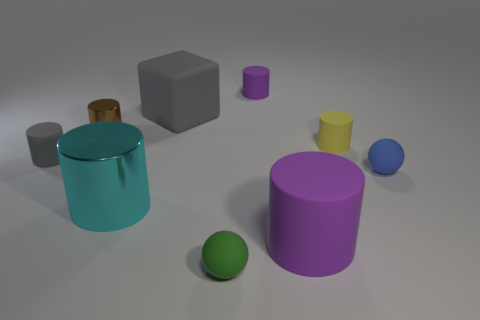Is the size of the brown thing in front of the block the same as the blue thing?
Ensure brevity in your answer.  Yes. How many large metallic cylinders have the same color as the block?
Provide a short and direct response. 0. Is the shape of the tiny brown metallic thing the same as the small yellow matte thing?
Provide a short and direct response. Yes. Are there any other things that are the same size as the gray matte block?
Offer a terse response. Yes. What is the size of the yellow thing that is the same shape as the big purple object?
Offer a terse response. Small. Is the number of brown shiny objects to the right of the blue thing greater than the number of large cyan metal cylinders that are on the left side of the large cyan shiny thing?
Your answer should be compact. No. Is the large cyan object made of the same material as the small sphere to the right of the green sphere?
Provide a short and direct response. No. Are there any other things that have the same shape as the tiny green matte thing?
Your answer should be compact. Yes. There is a tiny thing that is in front of the gray rubber cylinder and on the left side of the blue matte sphere; what is its color?
Offer a very short reply. Green. There is a large matte thing left of the small purple object; what is its shape?
Your response must be concise. Cube. 